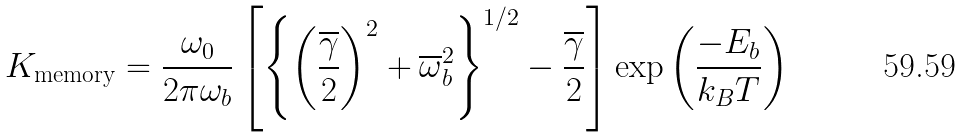Convert formula to latex. <formula><loc_0><loc_0><loc_500><loc_500>K _ { \text {memory} } = \frac { \omega _ { 0 } } { 2 \pi \omega _ { b } } \left [ \left \{ \left ( \frac { \overline { \gamma } } { 2 } \right ) ^ { 2 } + \overline { \omega } _ { b } ^ { 2 } \right \} ^ { 1 / 2 } - \frac { \overline { \gamma } } { 2 } \right ] \exp \left ( \frac { - E _ { b } } { k _ { B } T } \right )</formula> 